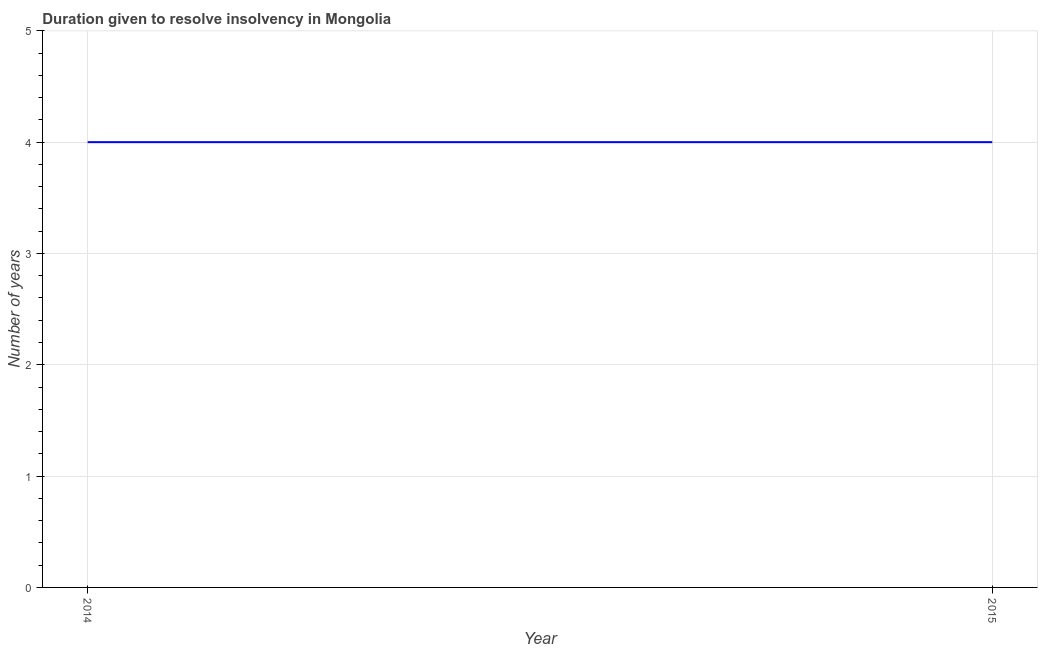What is the number of years to resolve insolvency in 2014?
Your answer should be very brief. 4. Across all years, what is the maximum number of years to resolve insolvency?
Provide a succinct answer. 4. Across all years, what is the minimum number of years to resolve insolvency?
Provide a succinct answer. 4. In which year was the number of years to resolve insolvency minimum?
Offer a terse response. 2014. What is the sum of the number of years to resolve insolvency?
Keep it short and to the point. 8. What is the ratio of the number of years to resolve insolvency in 2014 to that in 2015?
Offer a very short reply. 1. How many lines are there?
Your answer should be compact. 1. How many years are there in the graph?
Offer a very short reply. 2. Are the values on the major ticks of Y-axis written in scientific E-notation?
Provide a succinct answer. No. Does the graph contain any zero values?
Provide a short and direct response. No. Does the graph contain grids?
Your response must be concise. Yes. What is the title of the graph?
Your response must be concise. Duration given to resolve insolvency in Mongolia. What is the label or title of the X-axis?
Offer a terse response. Year. What is the label or title of the Y-axis?
Offer a terse response. Number of years. What is the Number of years of 2014?
Your response must be concise. 4. What is the Number of years in 2015?
Provide a succinct answer. 4. What is the difference between the Number of years in 2014 and 2015?
Provide a succinct answer. 0. What is the ratio of the Number of years in 2014 to that in 2015?
Offer a very short reply. 1. 